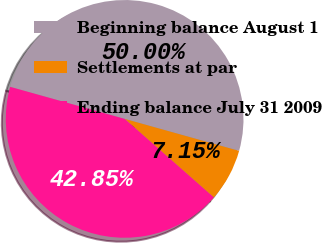Convert chart. <chart><loc_0><loc_0><loc_500><loc_500><pie_chart><fcel>Beginning balance August 1<fcel>Settlements at par<fcel>Ending balance July 31 2009<nl><fcel>50.0%<fcel>7.15%<fcel>42.85%<nl></chart> 